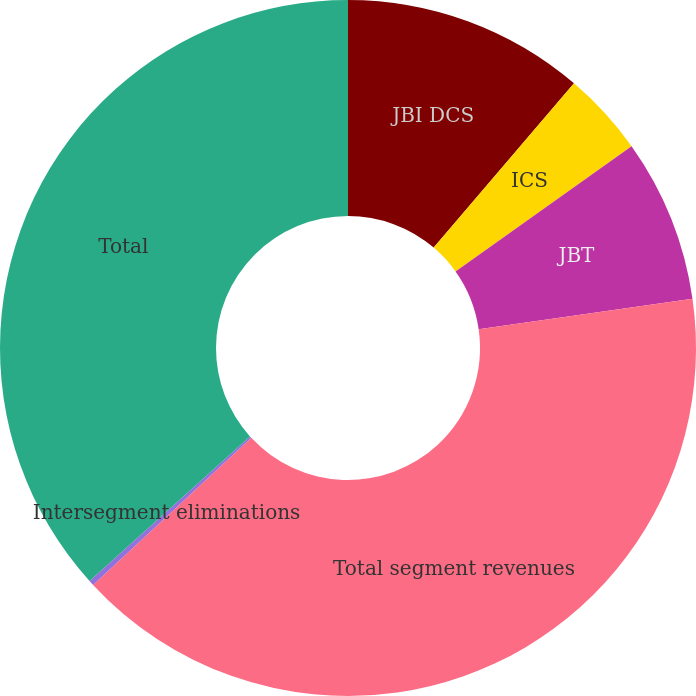Convert chart to OTSL. <chart><loc_0><loc_0><loc_500><loc_500><pie_chart><fcel>JBI DCS<fcel>ICS<fcel>JBT<fcel>Total segment revenues<fcel>Intersegment eliminations<fcel>Total<nl><fcel>11.25%<fcel>3.91%<fcel>7.58%<fcel>40.35%<fcel>0.24%<fcel>36.68%<nl></chart> 